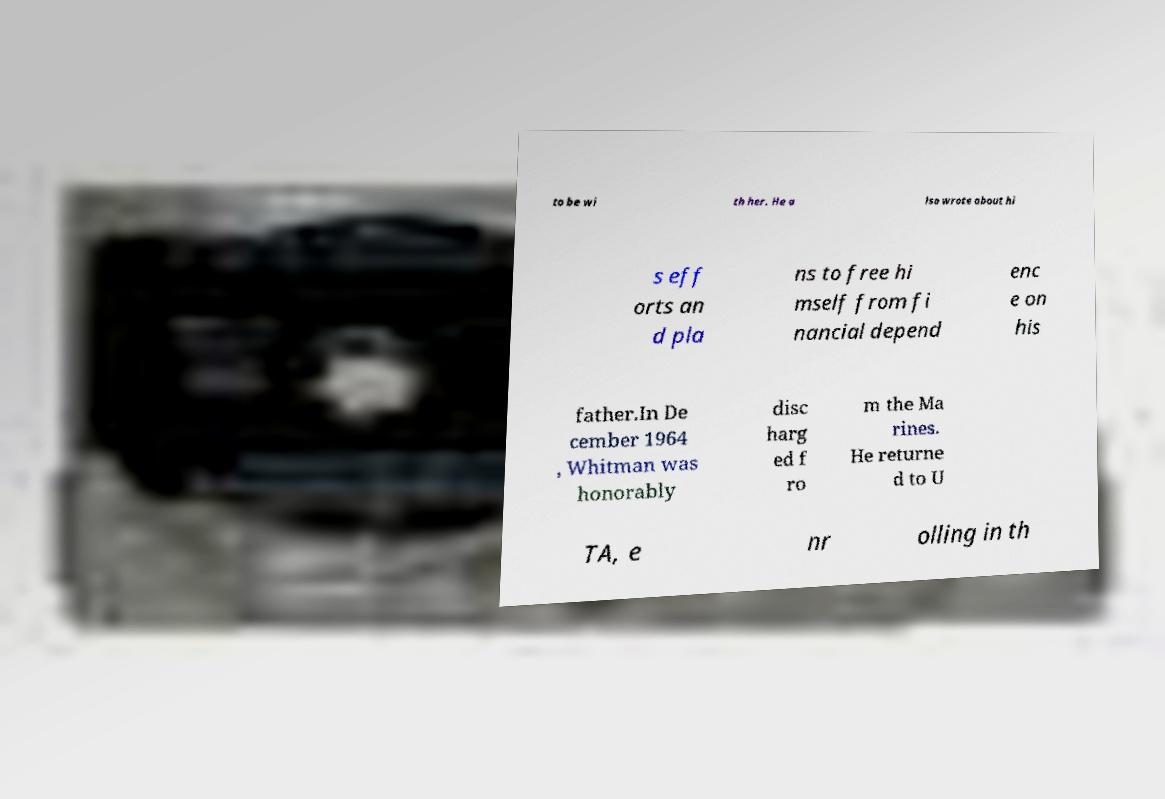Could you extract and type out the text from this image? to be wi th her. He a lso wrote about hi s eff orts an d pla ns to free hi mself from fi nancial depend enc e on his father.In De cember 1964 , Whitman was honorably disc harg ed f ro m the Ma rines. He returne d to U TA, e nr olling in th 